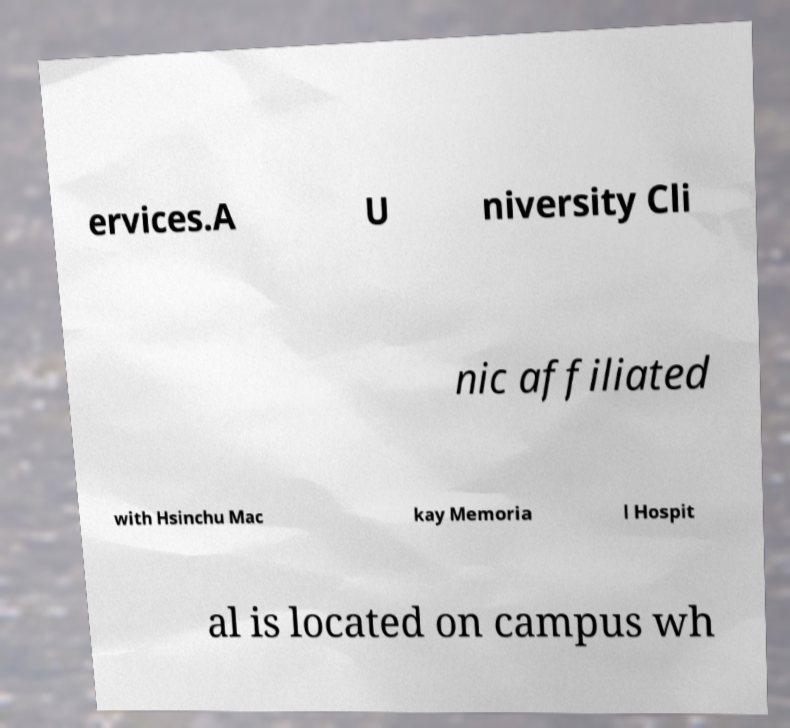There's text embedded in this image that I need extracted. Can you transcribe it verbatim? ervices.A U niversity Cli nic affiliated with Hsinchu Mac kay Memoria l Hospit al is located on campus wh 